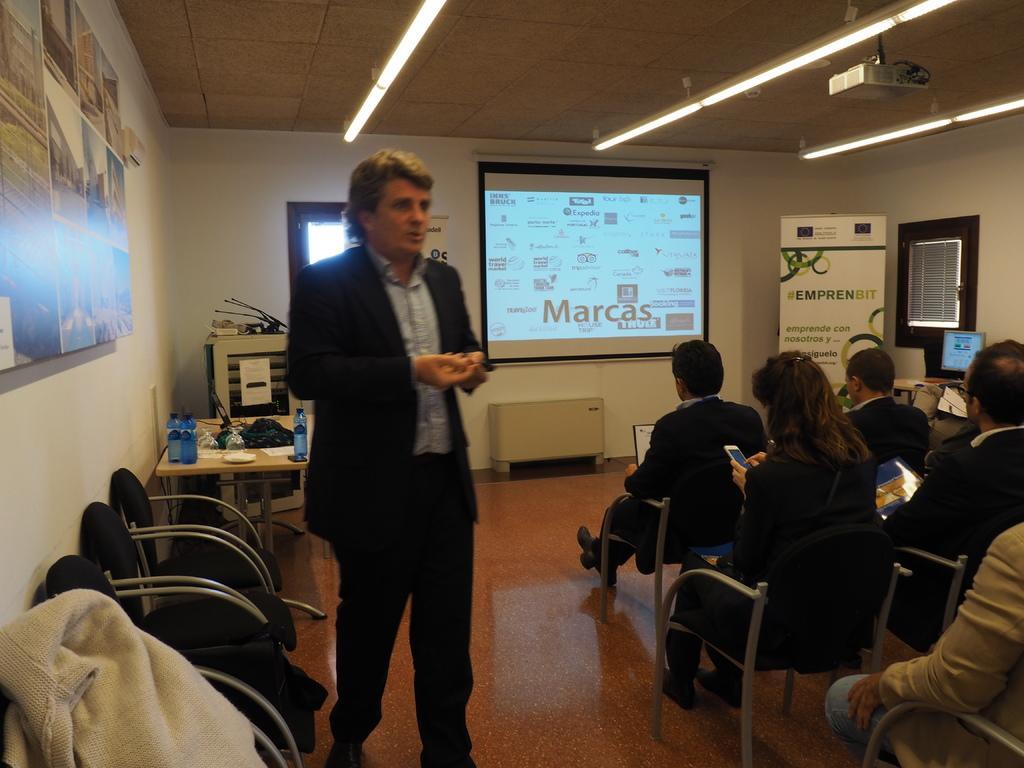Please provide a concise description of this image. A man is standing and speaking right side there are people sitting on the chairs. There is a light it's a projected image. 